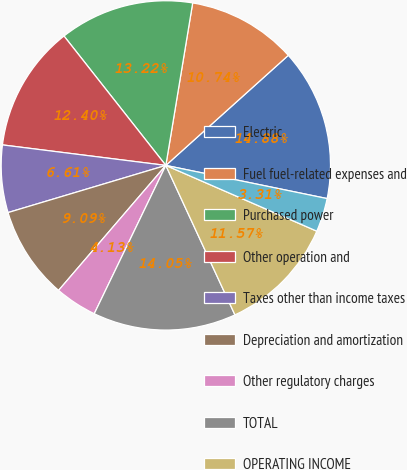Convert chart to OTSL. <chart><loc_0><loc_0><loc_500><loc_500><pie_chart><fcel>Electric<fcel>Fuel fuel-related expenses and<fcel>Purchased power<fcel>Other operation and<fcel>Taxes other than income taxes<fcel>Depreciation and amortization<fcel>Other regulatory charges<fcel>TOTAL<fcel>OPERATING INCOME<fcel>Allowance for equity funds<nl><fcel>14.88%<fcel>10.74%<fcel>13.22%<fcel>12.4%<fcel>6.61%<fcel>9.09%<fcel>4.13%<fcel>14.05%<fcel>11.57%<fcel>3.31%<nl></chart> 